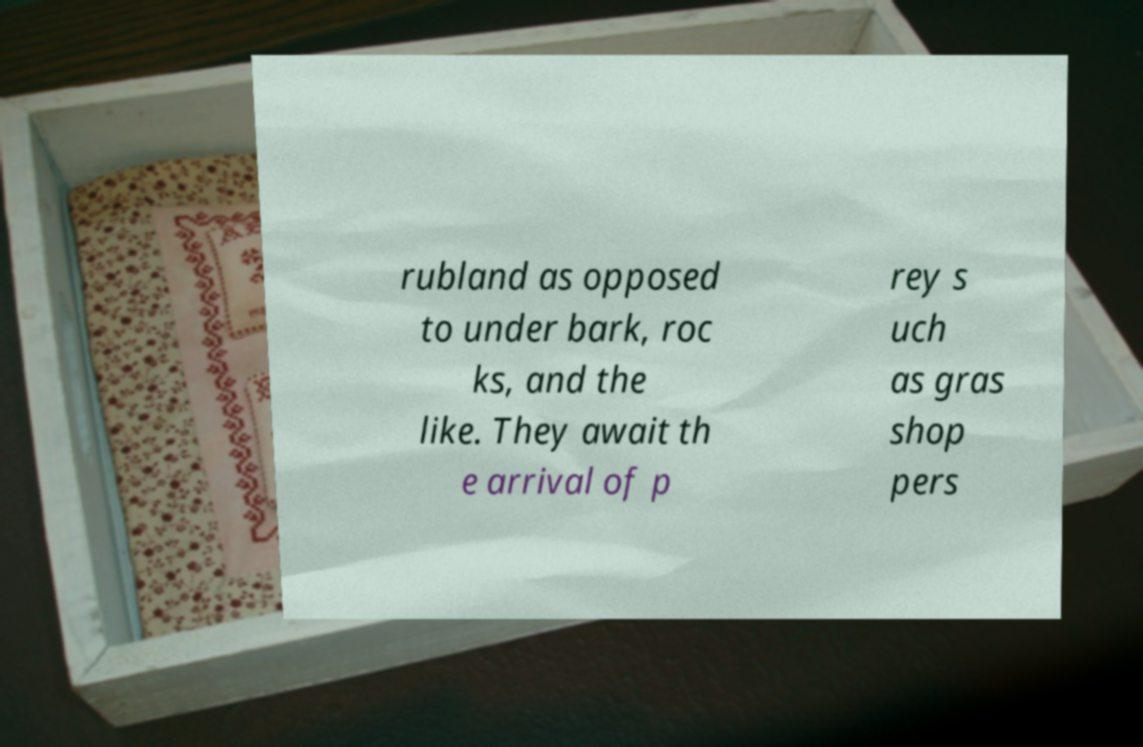Can you accurately transcribe the text from the provided image for me? rubland as opposed to under bark, roc ks, and the like. They await th e arrival of p rey s uch as gras shop pers 